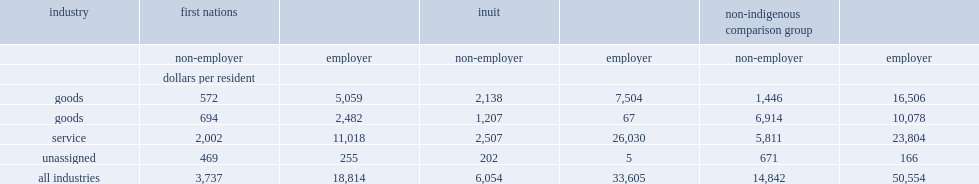For non-employer businesses at the all industries level, how many times are revenues per resident in non-indigenous csds more than those of such ventures in first nations csds? 3.971635. For non-employer businesses at the all industries level, how many times are revenues per resident in non-indigenous csds more than in inuit csds? 2.451602. For employer businesses at the all industries level, how many dollars do non-indigenous csds have revenues per resident? 50554.0. For employer businesses at the all industries level, how many dollars do first nations csds have revenues per resident? 18814.0. For employer businesses at the all industries level, how many dollars do inuit csds have revenues per resident? 33605.0. For non-employer businesses at the all industries level, how many times are revenues per resident in non-indigenous csds more than those of such ventures in first nations csds? 3.971635. For non-employer businesses at the all industries level, how many times are revenues per resident in non-indigenous csds more than in inuit csds? 2.451602. For employer businesses at the all industries level, how many dollars do non-indigenous csds have revenues per resident? 50554.0. For employer businesses at the all industries level, how many dollars do first nations csds have revenues per resident? 18814.0. For employer businesses at the all industries level, how many dollars do inuit csds have revenues per resident? 33605.0. 